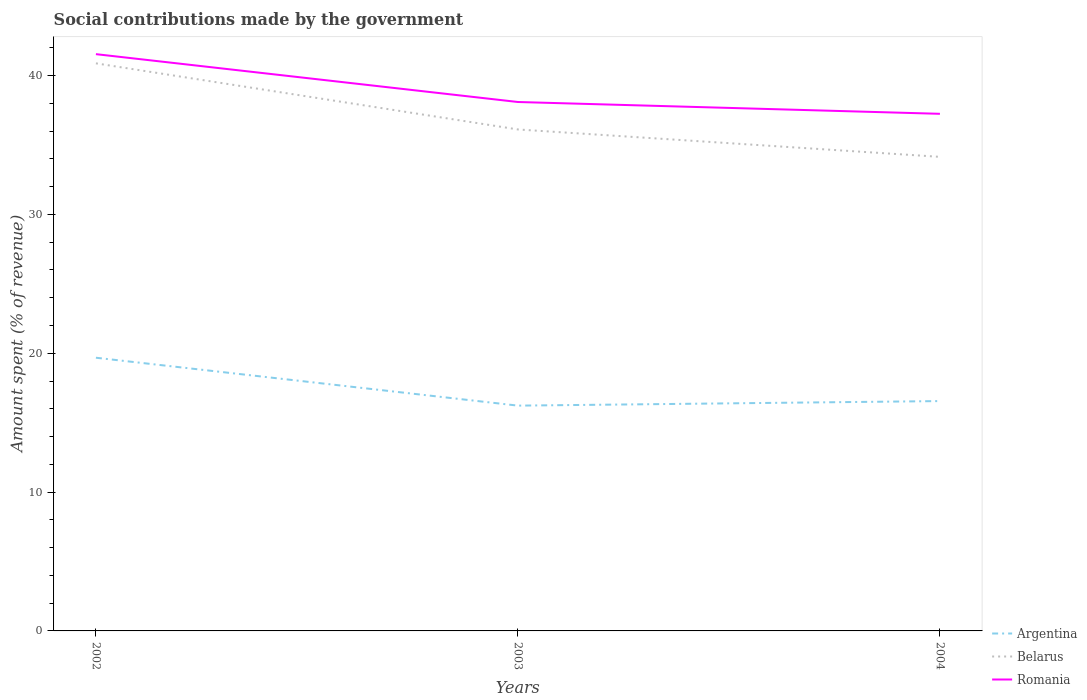How many different coloured lines are there?
Give a very brief answer. 3. Across all years, what is the maximum amount spent (in %) on social contributions in Romania?
Keep it short and to the point. 37.25. In which year was the amount spent (in %) on social contributions in Argentina maximum?
Give a very brief answer. 2003. What is the total amount spent (in %) on social contributions in Belarus in the graph?
Provide a succinct answer. 4.76. What is the difference between the highest and the second highest amount spent (in %) on social contributions in Argentina?
Give a very brief answer. 3.45. Is the amount spent (in %) on social contributions in Argentina strictly greater than the amount spent (in %) on social contributions in Belarus over the years?
Your answer should be very brief. Yes. How are the legend labels stacked?
Your answer should be compact. Vertical. What is the title of the graph?
Give a very brief answer. Social contributions made by the government. What is the label or title of the X-axis?
Your response must be concise. Years. What is the label or title of the Y-axis?
Offer a very short reply. Amount spent (% of revenue). What is the Amount spent (% of revenue) in Argentina in 2002?
Offer a very short reply. 19.68. What is the Amount spent (% of revenue) of Belarus in 2002?
Your answer should be very brief. 40.88. What is the Amount spent (% of revenue) of Romania in 2002?
Provide a succinct answer. 41.54. What is the Amount spent (% of revenue) of Argentina in 2003?
Give a very brief answer. 16.23. What is the Amount spent (% of revenue) in Belarus in 2003?
Provide a succinct answer. 36.12. What is the Amount spent (% of revenue) in Romania in 2003?
Give a very brief answer. 38.1. What is the Amount spent (% of revenue) in Argentina in 2004?
Give a very brief answer. 16.56. What is the Amount spent (% of revenue) of Belarus in 2004?
Your response must be concise. 34.15. What is the Amount spent (% of revenue) of Romania in 2004?
Offer a terse response. 37.25. Across all years, what is the maximum Amount spent (% of revenue) in Argentina?
Provide a succinct answer. 19.68. Across all years, what is the maximum Amount spent (% of revenue) in Belarus?
Provide a short and direct response. 40.88. Across all years, what is the maximum Amount spent (% of revenue) in Romania?
Your answer should be very brief. 41.54. Across all years, what is the minimum Amount spent (% of revenue) of Argentina?
Offer a very short reply. 16.23. Across all years, what is the minimum Amount spent (% of revenue) in Belarus?
Give a very brief answer. 34.15. Across all years, what is the minimum Amount spent (% of revenue) in Romania?
Make the answer very short. 37.25. What is the total Amount spent (% of revenue) of Argentina in the graph?
Provide a succinct answer. 52.46. What is the total Amount spent (% of revenue) in Belarus in the graph?
Your response must be concise. 111.15. What is the total Amount spent (% of revenue) of Romania in the graph?
Give a very brief answer. 116.89. What is the difference between the Amount spent (% of revenue) of Argentina in 2002 and that in 2003?
Make the answer very short. 3.45. What is the difference between the Amount spent (% of revenue) in Belarus in 2002 and that in 2003?
Give a very brief answer. 4.76. What is the difference between the Amount spent (% of revenue) of Romania in 2002 and that in 2003?
Ensure brevity in your answer.  3.45. What is the difference between the Amount spent (% of revenue) in Argentina in 2002 and that in 2004?
Give a very brief answer. 3.12. What is the difference between the Amount spent (% of revenue) in Belarus in 2002 and that in 2004?
Keep it short and to the point. 6.74. What is the difference between the Amount spent (% of revenue) in Romania in 2002 and that in 2004?
Offer a terse response. 4.3. What is the difference between the Amount spent (% of revenue) of Argentina in 2003 and that in 2004?
Offer a terse response. -0.33. What is the difference between the Amount spent (% of revenue) in Belarus in 2003 and that in 2004?
Provide a short and direct response. 1.97. What is the difference between the Amount spent (% of revenue) of Romania in 2003 and that in 2004?
Ensure brevity in your answer.  0.85. What is the difference between the Amount spent (% of revenue) of Argentina in 2002 and the Amount spent (% of revenue) of Belarus in 2003?
Your response must be concise. -16.44. What is the difference between the Amount spent (% of revenue) of Argentina in 2002 and the Amount spent (% of revenue) of Romania in 2003?
Provide a succinct answer. -18.42. What is the difference between the Amount spent (% of revenue) of Belarus in 2002 and the Amount spent (% of revenue) of Romania in 2003?
Keep it short and to the point. 2.78. What is the difference between the Amount spent (% of revenue) in Argentina in 2002 and the Amount spent (% of revenue) in Belarus in 2004?
Give a very brief answer. -14.47. What is the difference between the Amount spent (% of revenue) of Argentina in 2002 and the Amount spent (% of revenue) of Romania in 2004?
Keep it short and to the point. -17.57. What is the difference between the Amount spent (% of revenue) of Belarus in 2002 and the Amount spent (% of revenue) of Romania in 2004?
Provide a succinct answer. 3.63. What is the difference between the Amount spent (% of revenue) in Argentina in 2003 and the Amount spent (% of revenue) in Belarus in 2004?
Offer a terse response. -17.92. What is the difference between the Amount spent (% of revenue) of Argentina in 2003 and the Amount spent (% of revenue) of Romania in 2004?
Offer a very short reply. -21.02. What is the difference between the Amount spent (% of revenue) in Belarus in 2003 and the Amount spent (% of revenue) in Romania in 2004?
Keep it short and to the point. -1.13. What is the average Amount spent (% of revenue) of Argentina per year?
Give a very brief answer. 17.49. What is the average Amount spent (% of revenue) of Belarus per year?
Your answer should be compact. 37.05. What is the average Amount spent (% of revenue) of Romania per year?
Provide a succinct answer. 38.96. In the year 2002, what is the difference between the Amount spent (% of revenue) of Argentina and Amount spent (% of revenue) of Belarus?
Your answer should be compact. -21.2. In the year 2002, what is the difference between the Amount spent (% of revenue) in Argentina and Amount spent (% of revenue) in Romania?
Keep it short and to the point. -21.87. In the year 2002, what is the difference between the Amount spent (% of revenue) of Belarus and Amount spent (% of revenue) of Romania?
Provide a short and direct response. -0.66. In the year 2003, what is the difference between the Amount spent (% of revenue) of Argentina and Amount spent (% of revenue) of Belarus?
Your answer should be very brief. -19.89. In the year 2003, what is the difference between the Amount spent (% of revenue) of Argentina and Amount spent (% of revenue) of Romania?
Give a very brief answer. -21.87. In the year 2003, what is the difference between the Amount spent (% of revenue) in Belarus and Amount spent (% of revenue) in Romania?
Make the answer very short. -1.98. In the year 2004, what is the difference between the Amount spent (% of revenue) in Argentina and Amount spent (% of revenue) in Belarus?
Give a very brief answer. -17.59. In the year 2004, what is the difference between the Amount spent (% of revenue) of Argentina and Amount spent (% of revenue) of Romania?
Keep it short and to the point. -20.69. In the year 2004, what is the difference between the Amount spent (% of revenue) in Belarus and Amount spent (% of revenue) in Romania?
Your response must be concise. -3.1. What is the ratio of the Amount spent (% of revenue) in Argentina in 2002 to that in 2003?
Your response must be concise. 1.21. What is the ratio of the Amount spent (% of revenue) of Belarus in 2002 to that in 2003?
Offer a very short reply. 1.13. What is the ratio of the Amount spent (% of revenue) of Romania in 2002 to that in 2003?
Give a very brief answer. 1.09. What is the ratio of the Amount spent (% of revenue) of Argentina in 2002 to that in 2004?
Your answer should be compact. 1.19. What is the ratio of the Amount spent (% of revenue) in Belarus in 2002 to that in 2004?
Offer a very short reply. 1.2. What is the ratio of the Amount spent (% of revenue) in Romania in 2002 to that in 2004?
Provide a succinct answer. 1.12. What is the ratio of the Amount spent (% of revenue) in Argentina in 2003 to that in 2004?
Provide a short and direct response. 0.98. What is the ratio of the Amount spent (% of revenue) of Belarus in 2003 to that in 2004?
Your answer should be compact. 1.06. What is the ratio of the Amount spent (% of revenue) in Romania in 2003 to that in 2004?
Keep it short and to the point. 1.02. What is the difference between the highest and the second highest Amount spent (% of revenue) in Argentina?
Provide a short and direct response. 3.12. What is the difference between the highest and the second highest Amount spent (% of revenue) in Belarus?
Provide a short and direct response. 4.76. What is the difference between the highest and the second highest Amount spent (% of revenue) in Romania?
Your answer should be very brief. 3.45. What is the difference between the highest and the lowest Amount spent (% of revenue) of Argentina?
Offer a terse response. 3.45. What is the difference between the highest and the lowest Amount spent (% of revenue) of Belarus?
Offer a very short reply. 6.74. What is the difference between the highest and the lowest Amount spent (% of revenue) in Romania?
Offer a terse response. 4.3. 